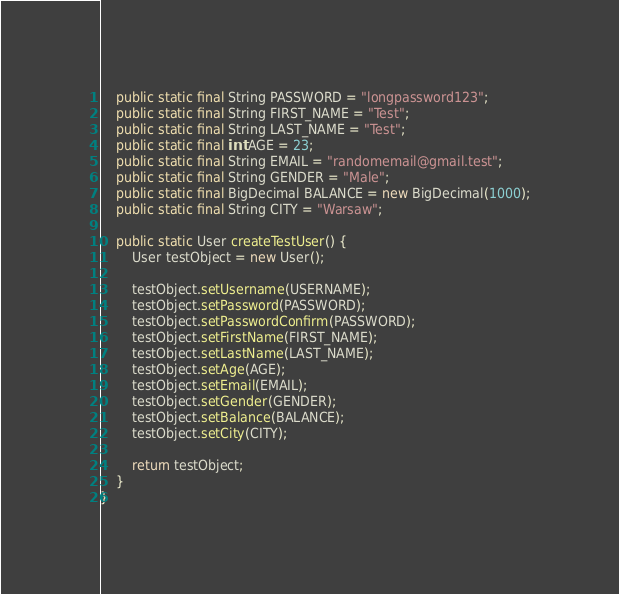<code> <loc_0><loc_0><loc_500><loc_500><_Java_>    public static final String PASSWORD = "longpassword123";
    public static final String FIRST_NAME = "Test";
    public static final String LAST_NAME = "Test";
    public static final int AGE = 23;
    public static final String EMAIL = "randomemail@gmail.test";
    public static final String GENDER = "Male";
    public static final BigDecimal BALANCE = new BigDecimal(1000);
    public static final String CITY = "Warsaw";

    public static User createTestUser() {
        User testObject = new User();

        testObject.setUsername(USERNAME);
        testObject.setPassword(PASSWORD);
        testObject.setPasswordConfirm(PASSWORD);
        testObject.setFirstName(FIRST_NAME);
        testObject.setLastName(LAST_NAME);
        testObject.setAge(AGE);
        testObject.setEmail(EMAIL);
        testObject.setGender(GENDER);
        testObject.setBalance(BALANCE);
        testObject.setCity(CITY);

        return testObject;
    }
}
</code> 